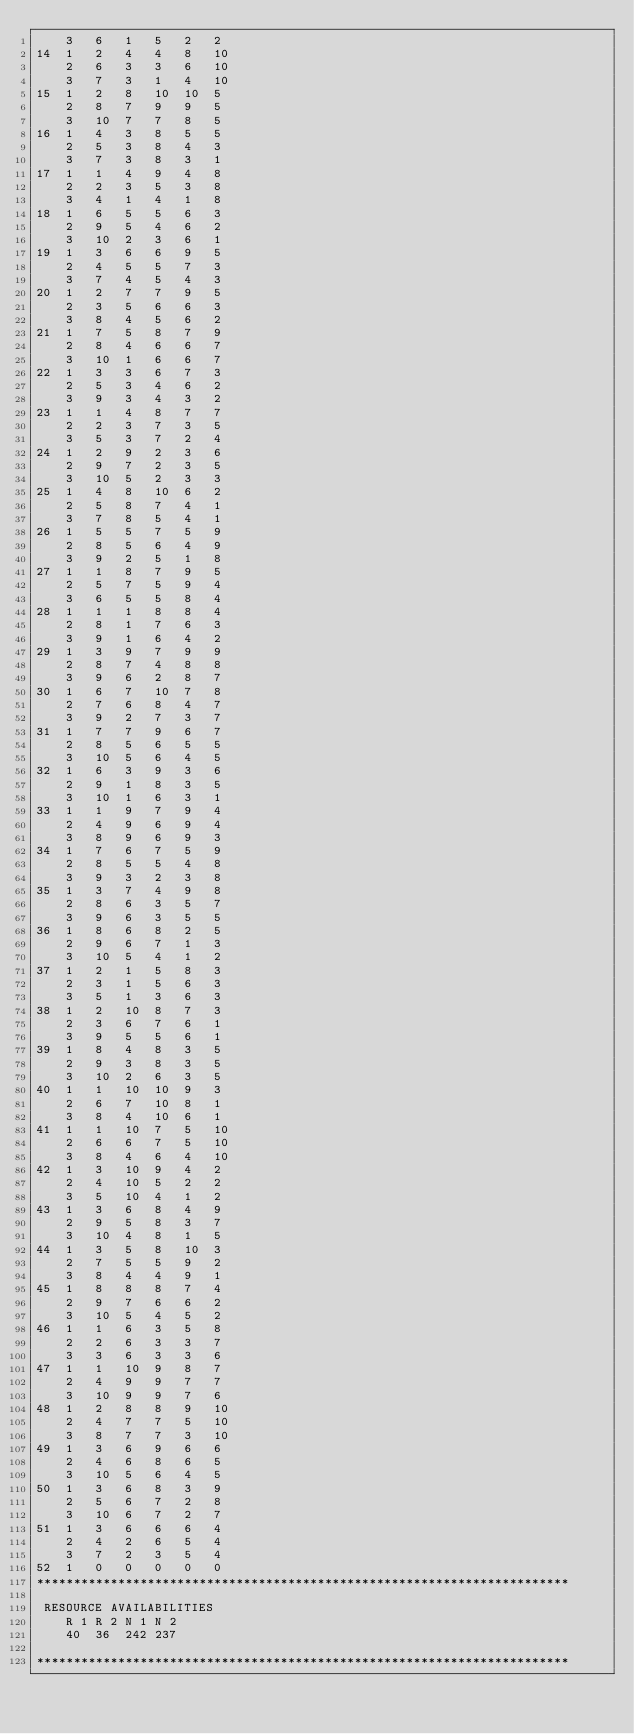<code> <loc_0><loc_0><loc_500><loc_500><_ObjectiveC_>	3	6	1	5	2	2	
14	1	2	4	4	8	10	
	2	6	3	3	6	10	
	3	7	3	1	4	10	
15	1	2	8	10	10	5	
	2	8	7	9	9	5	
	3	10	7	7	8	5	
16	1	4	3	8	5	5	
	2	5	3	8	4	3	
	3	7	3	8	3	1	
17	1	1	4	9	4	8	
	2	2	3	5	3	8	
	3	4	1	4	1	8	
18	1	6	5	5	6	3	
	2	9	5	4	6	2	
	3	10	2	3	6	1	
19	1	3	6	6	9	5	
	2	4	5	5	7	3	
	3	7	4	5	4	3	
20	1	2	7	7	9	5	
	2	3	5	6	6	3	
	3	8	4	5	6	2	
21	1	7	5	8	7	9	
	2	8	4	6	6	7	
	3	10	1	6	6	7	
22	1	3	3	6	7	3	
	2	5	3	4	6	2	
	3	9	3	4	3	2	
23	1	1	4	8	7	7	
	2	2	3	7	3	5	
	3	5	3	7	2	4	
24	1	2	9	2	3	6	
	2	9	7	2	3	5	
	3	10	5	2	3	3	
25	1	4	8	10	6	2	
	2	5	8	7	4	1	
	3	7	8	5	4	1	
26	1	5	5	7	5	9	
	2	8	5	6	4	9	
	3	9	2	5	1	8	
27	1	1	8	7	9	5	
	2	5	7	5	9	4	
	3	6	5	5	8	4	
28	1	1	1	8	8	4	
	2	8	1	7	6	3	
	3	9	1	6	4	2	
29	1	3	9	7	9	9	
	2	8	7	4	8	8	
	3	9	6	2	8	7	
30	1	6	7	10	7	8	
	2	7	6	8	4	7	
	3	9	2	7	3	7	
31	1	7	7	9	6	7	
	2	8	5	6	5	5	
	3	10	5	6	4	5	
32	1	6	3	9	3	6	
	2	9	1	8	3	5	
	3	10	1	6	3	1	
33	1	1	9	7	9	4	
	2	4	9	6	9	4	
	3	8	9	6	9	3	
34	1	7	6	7	5	9	
	2	8	5	5	4	8	
	3	9	3	2	3	8	
35	1	3	7	4	9	8	
	2	8	6	3	5	7	
	3	9	6	3	5	5	
36	1	8	6	8	2	5	
	2	9	6	7	1	3	
	3	10	5	4	1	2	
37	1	2	1	5	8	3	
	2	3	1	5	6	3	
	3	5	1	3	6	3	
38	1	2	10	8	7	3	
	2	3	6	7	6	1	
	3	9	5	5	6	1	
39	1	8	4	8	3	5	
	2	9	3	8	3	5	
	3	10	2	6	3	5	
40	1	1	10	10	9	3	
	2	6	7	10	8	1	
	3	8	4	10	6	1	
41	1	1	10	7	5	10	
	2	6	6	7	5	10	
	3	8	4	6	4	10	
42	1	3	10	9	4	2	
	2	4	10	5	2	2	
	3	5	10	4	1	2	
43	1	3	6	8	4	9	
	2	9	5	8	3	7	
	3	10	4	8	1	5	
44	1	3	5	8	10	3	
	2	7	5	5	9	2	
	3	8	4	4	9	1	
45	1	8	8	8	7	4	
	2	9	7	6	6	2	
	3	10	5	4	5	2	
46	1	1	6	3	5	8	
	2	2	6	3	3	7	
	3	3	6	3	3	6	
47	1	1	10	9	8	7	
	2	4	9	9	7	7	
	3	10	9	9	7	6	
48	1	2	8	8	9	10	
	2	4	7	7	5	10	
	3	8	7	7	3	10	
49	1	3	6	9	6	6	
	2	4	6	8	6	5	
	3	10	5	6	4	5	
50	1	3	6	8	3	9	
	2	5	6	7	2	8	
	3	10	6	7	2	7	
51	1	3	6	6	6	4	
	2	4	2	6	5	4	
	3	7	2	3	5	4	
52	1	0	0	0	0	0	
************************************************************************

 RESOURCE AVAILABILITIES 
	R 1	R 2	N 1	N 2
	40	36	242	237

************************************************************************
</code> 